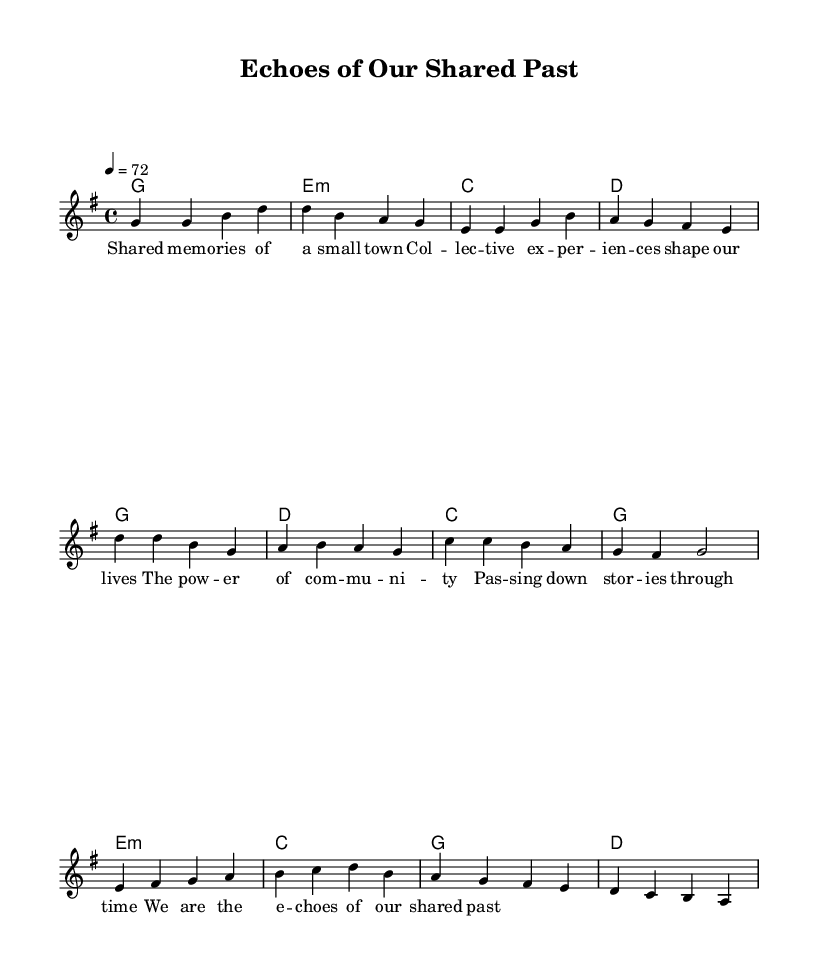What is the key signature of this music? The key signature is G major, which has one sharp (F#).
Answer: G major What is the time signature of this music? The time signature is 4/4, indicating four beats per measure.
Answer: 4/4 What is the tempo marking for this piece? The tempo marking indicates a speed of 72 beats per minute.
Answer: 72 What is the first chord in the verse? The first chord in the verse is G major, as indicated at the start of the harmony section.
Answer: G How many measures are in the chorus section? The chorus section consists of four measures, as counted from the melody and harmonies.
Answer: 4 What lyrical theme is present in this ballad? The lyrics focus on the themes of shared memories and community experiences, reflecting on the collective past.
Answer: Shared memories Which musical section contains the lyrics about "the power of community"? This line is found in the verse section, where the lyrics emphasize the importance of collective experiences.
Answer: Verse 